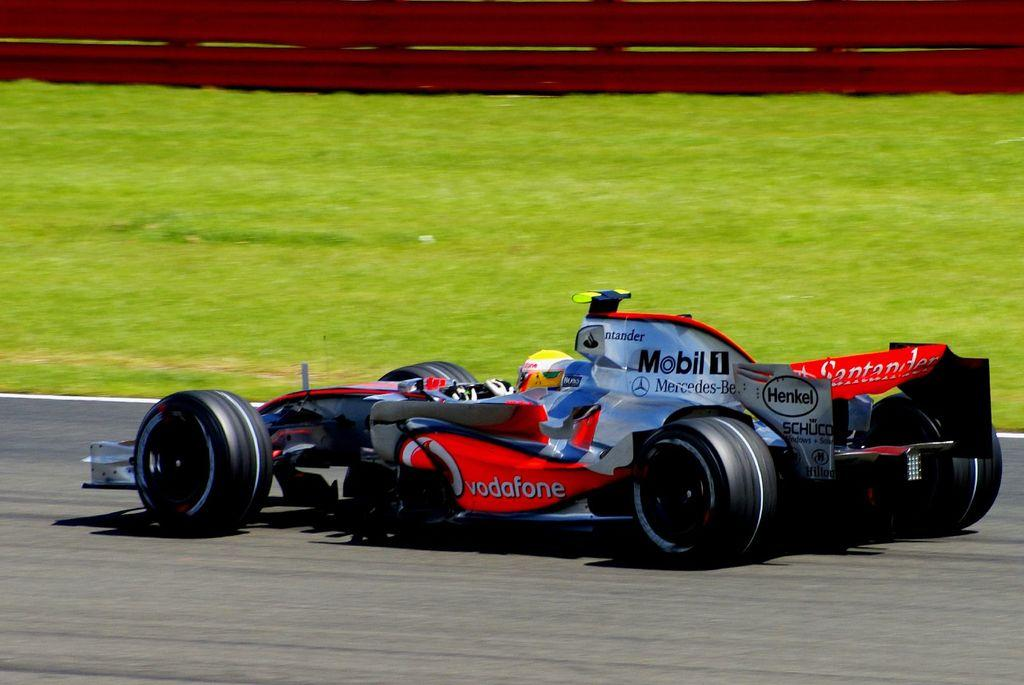What is on the road in the image? There is a vehicle on the road in the image. What type of vegetation can be seen in the image? There is grass visible in the image. What is in the background of the image? There is a fence in the background of the image. Where is the bed located in the image? There is no bed present in the image. What type of class is being taught in the image? There is no class or teaching activity depicted in the image. 